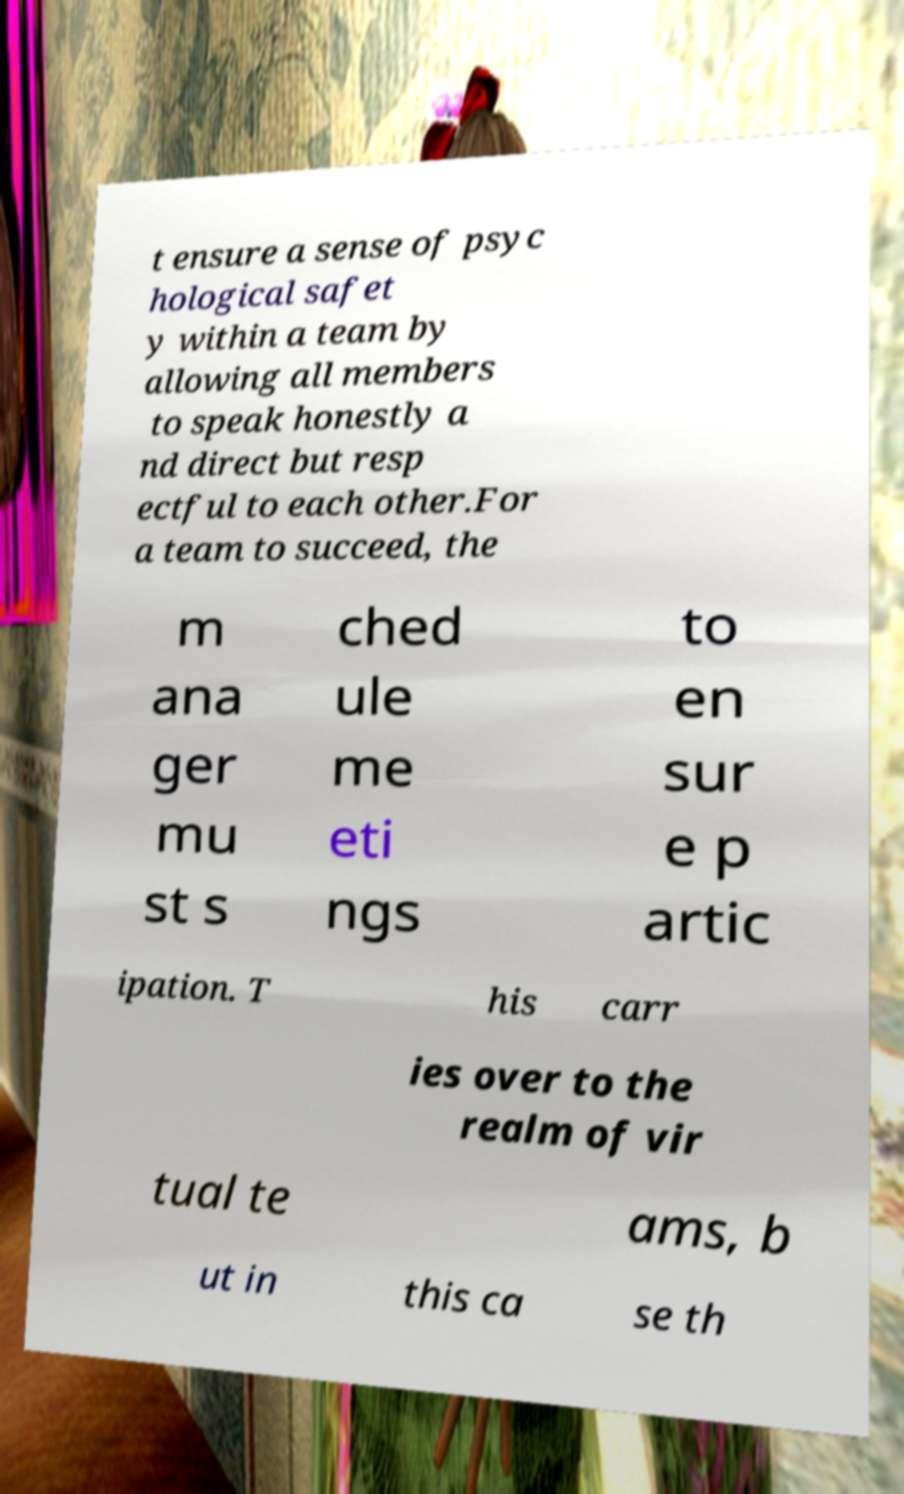Could you assist in decoding the text presented in this image and type it out clearly? t ensure a sense of psyc hological safet y within a team by allowing all members to speak honestly a nd direct but resp ectful to each other.For a team to succeed, the m ana ger mu st s ched ule me eti ngs to en sur e p artic ipation. T his carr ies over to the realm of vir tual te ams, b ut in this ca se th 